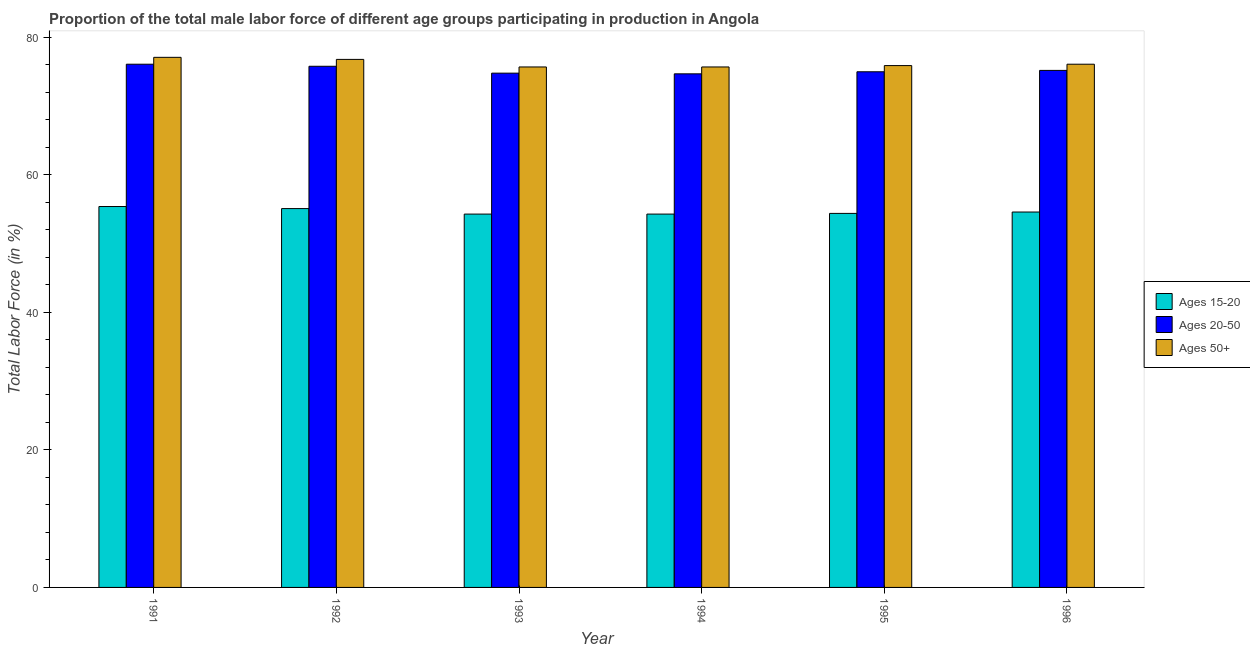How many different coloured bars are there?
Ensure brevity in your answer.  3. How many groups of bars are there?
Your answer should be compact. 6. Are the number of bars per tick equal to the number of legend labels?
Ensure brevity in your answer.  Yes. How many bars are there on the 5th tick from the right?
Provide a succinct answer. 3. In how many cases, is the number of bars for a given year not equal to the number of legend labels?
Give a very brief answer. 0. What is the percentage of male labor force within the age group 15-20 in 1994?
Give a very brief answer. 54.3. Across all years, what is the maximum percentage of male labor force above age 50?
Offer a terse response. 77.1. Across all years, what is the minimum percentage of male labor force within the age group 20-50?
Provide a short and direct response. 74.7. In which year was the percentage of male labor force within the age group 15-20 maximum?
Your answer should be compact. 1991. In which year was the percentage of male labor force above age 50 minimum?
Your answer should be very brief. 1993. What is the total percentage of male labor force within the age group 15-20 in the graph?
Your answer should be compact. 328.1. What is the difference between the percentage of male labor force within the age group 20-50 in 1993 and that in 1995?
Provide a succinct answer. -0.2. What is the difference between the percentage of male labor force within the age group 15-20 in 1996 and the percentage of male labor force above age 50 in 1991?
Keep it short and to the point. -0.8. What is the average percentage of male labor force above age 50 per year?
Your answer should be very brief. 76.22. In the year 1993, what is the difference between the percentage of male labor force within the age group 20-50 and percentage of male labor force above age 50?
Offer a very short reply. 0. In how many years, is the percentage of male labor force within the age group 20-50 greater than 56 %?
Provide a succinct answer. 6. What is the ratio of the percentage of male labor force within the age group 20-50 in 1991 to that in 1996?
Keep it short and to the point. 1.01. Is the difference between the percentage of male labor force within the age group 20-50 in 1992 and 1993 greater than the difference between the percentage of male labor force within the age group 15-20 in 1992 and 1993?
Your answer should be very brief. No. What is the difference between the highest and the second highest percentage of male labor force within the age group 20-50?
Ensure brevity in your answer.  0.3. What is the difference between the highest and the lowest percentage of male labor force above age 50?
Your answer should be compact. 1.4. In how many years, is the percentage of male labor force within the age group 15-20 greater than the average percentage of male labor force within the age group 15-20 taken over all years?
Your response must be concise. 2. Is the sum of the percentage of male labor force within the age group 20-50 in 1992 and 1993 greater than the maximum percentage of male labor force within the age group 15-20 across all years?
Your response must be concise. Yes. What does the 2nd bar from the left in 1993 represents?
Keep it short and to the point. Ages 20-50. What does the 2nd bar from the right in 1992 represents?
Your answer should be very brief. Ages 20-50. How many bars are there?
Offer a terse response. 18. How many years are there in the graph?
Ensure brevity in your answer.  6. What is the difference between two consecutive major ticks on the Y-axis?
Offer a terse response. 20. Are the values on the major ticks of Y-axis written in scientific E-notation?
Offer a very short reply. No. Where does the legend appear in the graph?
Keep it short and to the point. Center right. How are the legend labels stacked?
Ensure brevity in your answer.  Vertical. What is the title of the graph?
Provide a succinct answer. Proportion of the total male labor force of different age groups participating in production in Angola. Does "Primary" appear as one of the legend labels in the graph?
Provide a succinct answer. No. What is the label or title of the Y-axis?
Keep it short and to the point. Total Labor Force (in %). What is the Total Labor Force (in %) in Ages 15-20 in 1991?
Provide a short and direct response. 55.4. What is the Total Labor Force (in %) of Ages 20-50 in 1991?
Provide a short and direct response. 76.1. What is the Total Labor Force (in %) of Ages 50+ in 1991?
Provide a succinct answer. 77.1. What is the Total Labor Force (in %) of Ages 15-20 in 1992?
Your answer should be very brief. 55.1. What is the Total Labor Force (in %) of Ages 20-50 in 1992?
Your answer should be very brief. 75.8. What is the Total Labor Force (in %) in Ages 50+ in 1992?
Your answer should be very brief. 76.8. What is the Total Labor Force (in %) of Ages 15-20 in 1993?
Give a very brief answer. 54.3. What is the Total Labor Force (in %) of Ages 20-50 in 1993?
Provide a succinct answer. 74.8. What is the Total Labor Force (in %) of Ages 50+ in 1993?
Offer a very short reply. 75.7. What is the Total Labor Force (in %) of Ages 15-20 in 1994?
Make the answer very short. 54.3. What is the Total Labor Force (in %) in Ages 20-50 in 1994?
Keep it short and to the point. 74.7. What is the Total Labor Force (in %) in Ages 50+ in 1994?
Give a very brief answer. 75.7. What is the Total Labor Force (in %) in Ages 15-20 in 1995?
Ensure brevity in your answer.  54.4. What is the Total Labor Force (in %) in Ages 20-50 in 1995?
Give a very brief answer. 75. What is the Total Labor Force (in %) in Ages 50+ in 1995?
Provide a short and direct response. 75.9. What is the Total Labor Force (in %) of Ages 15-20 in 1996?
Ensure brevity in your answer.  54.6. What is the Total Labor Force (in %) of Ages 20-50 in 1996?
Ensure brevity in your answer.  75.2. What is the Total Labor Force (in %) in Ages 50+ in 1996?
Your response must be concise. 76.1. Across all years, what is the maximum Total Labor Force (in %) of Ages 15-20?
Your answer should be compact. 55.4. Across all years, what is the maximum Total Labor Force (in %) of Ages 20-50?
Give a very brief answer. 76.1. Across all years, what is the maximum Total Labor Force (in %) of Ages 50+?
Ensure brevity in your answer.  77.1. Across all years, what is the minimum Total Labor Force (in %) of Ages 15-20?
Ensure brevity in your answer.  54.3. Across all years, what is the minimum Total Labor Force (in %) in Ages 20-50?
Make the answer very short. 74.7. Across all years, what is the minimum Total Labor Force (in %) of Ages 50+?
Your answer should be compact. 75.7. What is the total Total Labor Force (in %) in Ages 15-20 in the graph?
Your response must be concise. 328.1. What is the total Total Labor Force (in %) in Ages 20-50 in the graph?
Your answer should be compact. 451.6. What is the total Total Labor Force (in %) in Ages 50+ in the graph?
Provide a succinct answer. 457.3. What is the difference between the Total Labor Force (in %) of Ages 15-20 in 1991 and that in 1992?
Offer a very short reply. 0.3. What is the difference between the Total Labor Force (in %) in Ages 50+ in 1991 and that in 1992?
Keep it short and to the point. 0.3. What is the difference between the Total Labor Force (in %) in Ages 15-20 in 1991 and that in 1993?
Your answer should be very brief. 1.1. What is the difference between the Total Labor Force (in %) of Ages 50+ in 1991 and that in 1993?
Your answer should be very brief. 1.4. What is the difference between the Total Labor Force (in %) in Ages 50+ in 1991 and that in 1994?
Offer a terse response. 1.4. What is the difference between the Total Labor Force (in %) of Ages 50+ in 1991 and that in 1995?
Provide a succinct answer. 1.2. What is the difference between the Total Labor Force (in %) in Ages 15-20 in 1991 and that in 1996?
Offer a very short reply. 0.8. What is the difference between the Total Labor Force (in %) of Ages 50+ in 1991 and that in 1996?
Give a very brief answer. 1. What is the difference between the Total Labor Force (in %) in Ages 15-20 in 1992 and that in 1993?
Your answer should be very brief. 0.8. What is the difference between the Total Labor Force (in %) of Ages 50+ in 1992 and that in 1993?
Your response must be concise. 1.1. What is the difference between the Total Labor Force (in %) in Ages 15-20 in 1992 and that in 1994?
Ensure brevity in your answer.  0.8. What is the difference between the Total Labor Force (in %) in Ages 20-50 in 1992 and that in 1994?
Offer a very short reply. 1.1. What is the difference between the Total Labor Force (in %) in Ages 50+ in 1992 and that in 1994?
Provide a short and direct response. 1.1. What is the difference between the Total Labor Force (in %) in Ages 15-20 in 1992 and that in 1995?
Provide a short and direct response. 0.7. What is the difference between the Total Labor Force (in %) of Ages 20-50 in 1992 and that in 1996?
Provide a succinct answer. 0.6. What is the difference between the Total Labor Force (in %) of Ages 20-50 in 1993 and that in 1995?
Your answer should be compact. -0.2. What is the difference between the Total Labor Force (in %) of Ages 50+ in 1993 and that in 1995?
Keep it short and to the point. -0.2. What is the difference between the Total Labor Force (in %) of Ages 20-50 in 1993 and that in 1996?
Your answer should be compact. -0.4. What is the difference between the Total Labor Force (in %) of Ages 50+ in 1994 and that in 1995?
Your answer should be very brief. -0.2. What is the difference between the Total Labor Force (in %) of Ages 15-20 in 1994 and that in 1996?
Offer a very short reply. -0.3. What is the difference between the Total Labor Force (in %) of Ages 20-50 in 1994 and that in 1996?
Your answer should be compact. -0.5. What is the difference between the Total Labor Force (in %) of Ages 50+ in 1994 and that in 1996?
Offer a very short reply. -0.4. What is the difference between the Total Labor Force (in %) in Ages 15-20 in 1995 and that in 1996?
Your response must be concise. -0.2. What is the difference between the Total Labor Force (in %) of Ages 20-50 in 1995 and that in 1996?
Offer a very short reply. -0.2. What is the difference between the Total Labor Force (in %) in Ages 50+ in 1995 and that in 1996?
Your answer should be very brief. -0.2. What is the difference between the Total Labor Force (in %) in Ages 15-20 in 1991 and the Total Labor Force (in %) in Ages 20-50 in 1992?
Keep it short and to the point. -20.4. What is the difference between the Total Labor Force (in %) in Ages 15-20 in 1991 and the Total Labor Force (in %) in Ages 50+ in 1992?
Ensure brevity in your answer.  -21.4. What is the difference between the Total Labor Force (in %) of Ages 20-50 in 1991 and the Total Labor Force (in %) of Ages 50+ in 1992?
Your response must be concise. -0.7. What is the difference between the Total Labor Force (in %) in Ages 15-20 in 1991 and the Total Labor Force (in %) in Ages 20-50 in 1993?
Provide a short and direct response. -19.4. What is the difference between the Total Labor Force (in %) of Ages 15-20 in 1991 and the Total Labor Force (in %) of Ages 50+ in 1993?
Ensure brevity in your answer.  -20.3. What is the difference between the Total Labor Force (in %) in Ages 20-50 in 1991 and the Total Labor Force (in %) in Ages 50+ in 1993?
Make the answer very short. 0.4. What is the difference between the Total Labor Force (in %) in Ages 15-20 in 1991 and the Total Labor Force (in %) in Ages 20-50 in 1994?
Provide a short and direct response. -19.3. What is the difference between the Total Labor Force (in %) of Ages 15-20 in 1991 and the Total Labor Force (in %) of Ages 50+ in 1994?
Ensure brevity in your answer.  -20.3. What is the difference between the Total Labor Force (in %) of Ages 15-20 in 1991 and the Total Labor Force (in %) of Ages 20-50 in 1995?
Offer a terse response. -19.6. What is the difference between the Total Labor Force (in %) of Ages 15-20 in 1991 and the Total Labor Force (in %) of Ages 50+ in 1995?
Give a very brief answer. -20.5. What is the difference between the Total Labor Force (in %) in Ages 20-50 in 1991 and the Total Labor Force (in %) in Ages 50+ in 1995?
Offer a terse response. 0.2. What is the difference between the Total Labor Force (in %) of Ages 15-20 in 1991 and the Total Labor Force (in %) of Ages 20-50 in 1996?
Your answer should be very brief. -19.8. What is the difference between the Total Labor Force (in %) in Ages 15-20 in 1991 and the Total Labor Force (in %) in Ages 50+ in 1996?
Your response must be concise. -20.7. What is the difference between the Total Labor Force (in %) of Ages 15-20 in 1992 and the Total Labor Force (in %) of Ages 20-50 in 1993?
Provide a succinct answer. -19.7. What is the difference between the Total Labor Force (in %) of Ages 15-20 in 1992 and the Total Labor Force (in %) of Ages 50+ in 1993?
Give a very brief answer. -20.6. What is the difference between the Total Labor Force (in %) of Ages 20-50 in 1992 and the Total Labor Force (in %) of Ages 50+ in 1993?
Offer a terse response. 0.1. What is the difference between the Total Labor Force (in %) in Ages 15-20 in 1992 and the Total Labor Force (in %) in Ages 20-50 in 1994?
Your response must be concise. -19.6. What is the difference between the Total Labor Force (in %) of Ages 15-20 in 1992 and the Total Labor Force (in %) of Ages 50+ in 1994?
Your answer should be compact. -20.6. What is the difference between the Total Labor Force (in %) of Ages 15-20 in 1992 and the Total Labor Force (in %) of Ages 20-50 in 1995?
Offer a terse response. -19.9. What is the difference between the Total Labor Force (in %) of Ages 15-20 in 1992 and the Total Labor Force (in %) of Ages 50+ in 1995?
Provide a short and direct response. -20.8. What is the difference between the Total Labor Force (in %) in Ages 20-50 in 1992 and the Total Labor Force (in %) in Ages 50+ in 1995?
Provide a succinct answer. -0.1. What is the difference between the Total Labor Force (in %) in Ages 15-20 in 1992 and the Total Labor Force (in %) in Ages 20-50 in 1996?
Offer a very short reply. -20.1. What is the difference between the Total Labor Force (in %) in Ages 20-50 in 1992 and the Total Labor Force (in %) in Ages 50+ in 1996?
Your answer should be compact. -0.3. What is the difference between the Total Labor Force (in %) in Ages 15-20 in 1993 and the Total Labor Force (in %) in Ages 20-50 in 1994?
Provide a succinct answer. -20.4. What is the difference between the Total Labor Force (in %) of Ages 15-20 in 1993 and the Total Labor Force (in %) of Ages 50+ in 1994?
Make the answer very short. -21.4. What is the difference between the Total Labor Force (in %) in Ages 20-50 in 1993 and the Total Labor Force (in %) in Ages 50+ in 1994?
Provide a succinct answer. -0.9. What is the difference between the Total Labor Force (in %) in Ages 15-20 in 1993 and the Total Labor Force (in %) in Ages 20-50 in 1995?
Provide a short and direct response. -20.7. What is the difference between the Total Labor Force (in %) in Ages 15-20 in 1993 and the Total Labor Force (in %) in Ages 50+ in 1995?
Provide a short and direct response. -21.6. What is the difference between the Total Labor Force (in %) in Ages 15-20 in 1993 and the Total Labor Force (in %) in Ages 20-50 in 1996?
Provide a succinct answer. -20.9. What is the difference between the Total Labor Force (in %) in Ages 15-20 in 1993 and the Total Labor Force (in %) in Ages 50+ in 1996?
Offer a very short reply. -21.8. What is the difference between the Total Labor Force (in %) in Ages 15-20 in 1994 and the Total Labor Force (in %) in Ages 20-50 in 1995?
Provide a short and direct response. -20.7. What is the difference between the Total Labor Force (in %) in Ages 15-20 in 1994 and the Total Labor Force (in %) in Ages 50+ in 1995?
Your response must be concise. -21.6. What is the difference between the Total Labor Force (in %) in Ages 20-50 in 1994 and the Total Labor Force (in %) in Ages 50+ in 1995?
Provide a succinct answer. -1.2. What is the difference between the Total Labor Force (in %) in Ages 15-20 in 1994 and the Total Labor Force (in %) in Ages 20-50 in 1996?
Provide a succinct answer. -20.9. What is the difference between the Total Labor Force (in %) in Ages 15-20 in 1994 and the Total Labor Force (in %) in Ages 50+ in 1996?
Offer a terse response. -21.8. What is the difference between the Total Labor Force (in %) of Ages 15-20 in 1995 and the Total Labor Force (in %) of Ages 20-50 in 1996?
Offer a terse response. -20.8. What is the difference between the Total Labor Force (in %) in Ages 15-20 in 1995 and the Total Labor Force (in %) in Ages 50+ in 1996?
Provide a succinct answer. -21.7. What is the difference between the Total Labor Force (in %) of Ages 20-50 in 1995 and the Total Labor Force (in %) of Ages 50+ in 1996?
Provide a short and direct response. -1.1. What is the average Total Labor Force (in %) in Ages 15-20 per year?
Your answer should be compact. 54.68. What is the average Total Labor Force (in %) in Ages 20-50 per year?
Keep it short and to the point. 75.27. What is the average Total Labor Force (in %) of Ages 50+ per year?
Ensure brevity in your answer.  76.22. In the year 1991, what is the difference between the Total Labor Force (in %) of Ages 15-20 and Total Labor Force (in %) of Ages 20-50?
Give a very brief answer. -20.7. In the year 1991, what is the difference between the Total Labor Force (in %) in Ages 15-20 and Total Labor Force (in %) in Ages 50+?
Offer a terse response. -21.7. In the year 1991, what is the difference between the Total Labor Force (in %) of Ages 20-50 and Total Labor Force (in %) of Ages 50+?
Provide a succinct answer. -1. In the year 1992, what is the difference between the Total Labor Force (in %) of Ages 15-20 and Total Labor Force (in %) of Ages 20-50?
Give a very brief answer. -20.7. In the year 1992, what is the difference between the Total Labor Force (in %) in Ages 15-20 and Total Labor Force (in %) in Ages 50+?
Provide a succinct answer. -21.7. In the year 1993, what is the difference between the Total Labor Force (in %) in Ages 15-20 and Total Labor Force (in %) in Ages 20-50?
Your answer should be very brief. -20.5. In the year 1993, what is the difference between the Total Labor Force (in %) of Ages 15-20 and Total Labor Force (in %) of Ages 50+?
Your response must be concise. -21.4. In the year 1994, what is the difference between the Total Labor Force (in %) of Ages 15-20 and Total Labor Force (in %) of Ages 20-50?
Your answer should be compact. -20.4. In the year 1994, what is the difference between the Total Labor Force (in %) of Ages 15-20 and Total Labor Force (in %) of Ages 50+?
Keep it short and to the point. -21.4. In the year 1995, what is the difference between the Total Labor Force (in %) of Ages 15-20 and Total Labor Force (in %) of Ages 20-50?
Provide a short and direct response. -20.6. In the year 1995, what is the difference between the Total Labor Force (in %) in Ages 15-20 and Total Labor Force (in %) in Ages 50+?
Offer a terse response. -21.5. In the year 1995, what is the difference between the Total Labor Force (in %) in Ages 20-50 and Total Labor Force (in %) in Ages 50+?
Your response must be concise. -0.9. In the year 1996, what is the difference between the Total Labor Force (in %) of Ages 15-20 and Total Labor Force (in %) of Ages 20-50?
Offer a very short reply. -20.6. In the year 1996, what is the difference between the Total Labor Force (in %) in Ages 15-20 and Total Labor Force (in %) in Ages 50+?
Keep it short and to the point. -21.5. In the year 1996, what is the difference between the Total Labor Force (in %) of Ages 20-50 and Total Labor Force (in %) of Ages 50+?
Offer a very short reply. -0.9. What is the ratio of the Total Labor Force (in %) of Ages 15-20 in 1991 to that in 1992?
Give a very brief answer. 1.01. What is the ratio of the Total Labor Force (in %) in Ages 50+ in 1991 to that in 1992?
Make the answer very short. 1. What is the ratio of the Total Labor Force (in %) in Ages 15-20 in 1991 to that in 1993?
Give a very brief answer. 1.02. What is the ratio of the Total Labor Force (in %) in Ages 20-50 in 1991 to that in 1993?
Offer a very short reply. 1.02. What is the ratio of the Total Labor Force (in %) in Ages 50+ in 1991 to that in 1993?
Give a very brief answer. 1.02. What is the ratio of the Total Labor Force (in %) in Ages 15-20 in 1991 to that in 1994?
Provide a succinct answer. 1.02. What is the ratio of the Total Labor Force (in %) of Ages 20-50 in 1991 to that in 1994?
Offer a terse response. 1.02. What is the ratio of the Total Labor Force (in %) in Ages 50+ in 1991 to that in 1994?
Give a very brief answer. 1.02. What is the ratio of the Total Labor Force (in %) of Ages 15-20 in 1991 to that in 1995?
Your response must be concise. 1.02. What is the ratio of the Total Labor Force (in %) in Ages 20-50 in 1991 to that in 1995?
Keep it short and to the point. 1.01. What is the ratio of the Total Labor Force (in %) in Ages 50+ in 1991 to that in 1995?
Your response must be concise. 1.02. What is the ratio of the Total Labor Force (in %) in Ages 15-20 in 1991 to that in 1996?
Provide a succinct answer. 1.01. What is the ratio of the Total Labor Force (in %) of Ages 20-50 in 1991 to that in 1996?
Offer a terse response. 1.01. What is the ratio of the Total Labor Force (in %) in Ages 50+ in 1991 to that in 1996?
Offer a very short reply. 1.01. What is the ratio of the Total Labor Force (in %) of Ages 15-20 in 1992 to that in 1993?
Offer a very short reply. 1.01. What is the ratio of the Total Labor Force (in %) in Ages 20-50 in 1992 to that in 1993?
Offer a terse response. 1.01. What is the ratio of the Total Labor Force (in %) of Ages 50+ in 1992 to that in 1993?
Offer a very short reply. 1.01. What is the ratio of the Total Labor Force (in %) in Ages 15-20 in 1992 to that in 1994?
Provide a succinct answer. 1.01. What is the ratio of the Total Labor Force (in %) in Ages 20-50 in 1992 to that in 1994?
Offer a terse response. 1.01. What is the ratio of the Total Labor Force (in %) of Ages 50+ in 1992 to that in 1994?
Provide a short and direct response. 1.01. What is the ratio of the Total Labor Force (in %) in Ages 15-20 in 1992 to that in 1995?
Your answer should be compact. 1.01. What is the ratio of the Total Labor Force (in %) in Ages 20-50 in 1992 to that in 1995?
Keep it short and to the point. 1.01. What is the ratio of the Total Labor Force (in %) in Ages 50+ in 1992 to that in 1995?
Ensure brevity in your answer.  1.01. What is the ratio of the Total Labor Force (in %) in Ages 15-20 in 1992 to that in 1996?
Offer a terse response. 1.01. What is the ratio of the Total Labor Force (in %) in Ages 50+ in 1992 to that in 1996?
Offer a very short reply. 1.01. What is the ratio of the Total Labor Force (in %) in Ages 15-20 in 1993 to that in 1994?
Provide a short and direct response. 1. What is the ratio of the Total Labor Force (in %) of Ages 20-50 in 1993 to that in 1994?
Provide a short and direct response. 1. What is the ratio of the Total Labor Force (in %) in Ages 50+ in 1993 to that in 1994?
Your response must be concise. 1. What is the ratio of the Total Labor Force (in %) of Ages 50+ in 1993 to that in 1995?
Provide a short and direct response. 1. What is the ratio of the Total Labor Force (in %) in Ages 50+ in 1993 to that in 1996?
Your answer should be compact. 0.99. What is the ratio of the Total Labor Force (in %) in Ages 15-20 in 1994 to that in 1995?
Provide a short and direct response. 1. What is the ratio of the Total Labor Force (in %) in Ages 20-50 in 1994 to that in 1995?
Give a very brief answer. 1. What is the ratio of the Total Labor Force (in %) of Ages 20-50 in 1994 to that in 1996?
Your answer should be very brief. 0.99. What is the ratio of the Total Labor Force (in %) in Ages 15-20 in 1995 to that in 1996?
Make the answer very short. 1. What is the ratio of the Total Labor Force (in %) of Ages 20-50 in 1995 to that in 1996?
Your answer should be compact. 1. What is the ratio of the Total Labor Force (in %) of Ages 50+ in 1995 to that in 1996?
Offer a terse response. 1. What is the difference between the highest and the second highest Total Labor Force (in %) in Ages 50+?
Ensure brevity in your answer.  0.3. What is the difference between the highest and the lowest Total Labor Force (in %) of Ages 50+?
Make the answer very short. 1.4. 